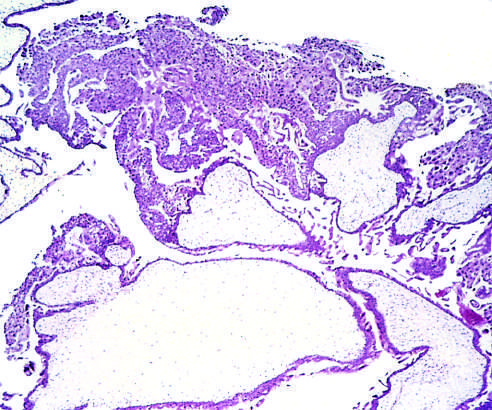what are evident in this microscopic image?
Answer the question using a single word or phrase. Distended hydropic villi and proliferation of the chorionic epithelium 